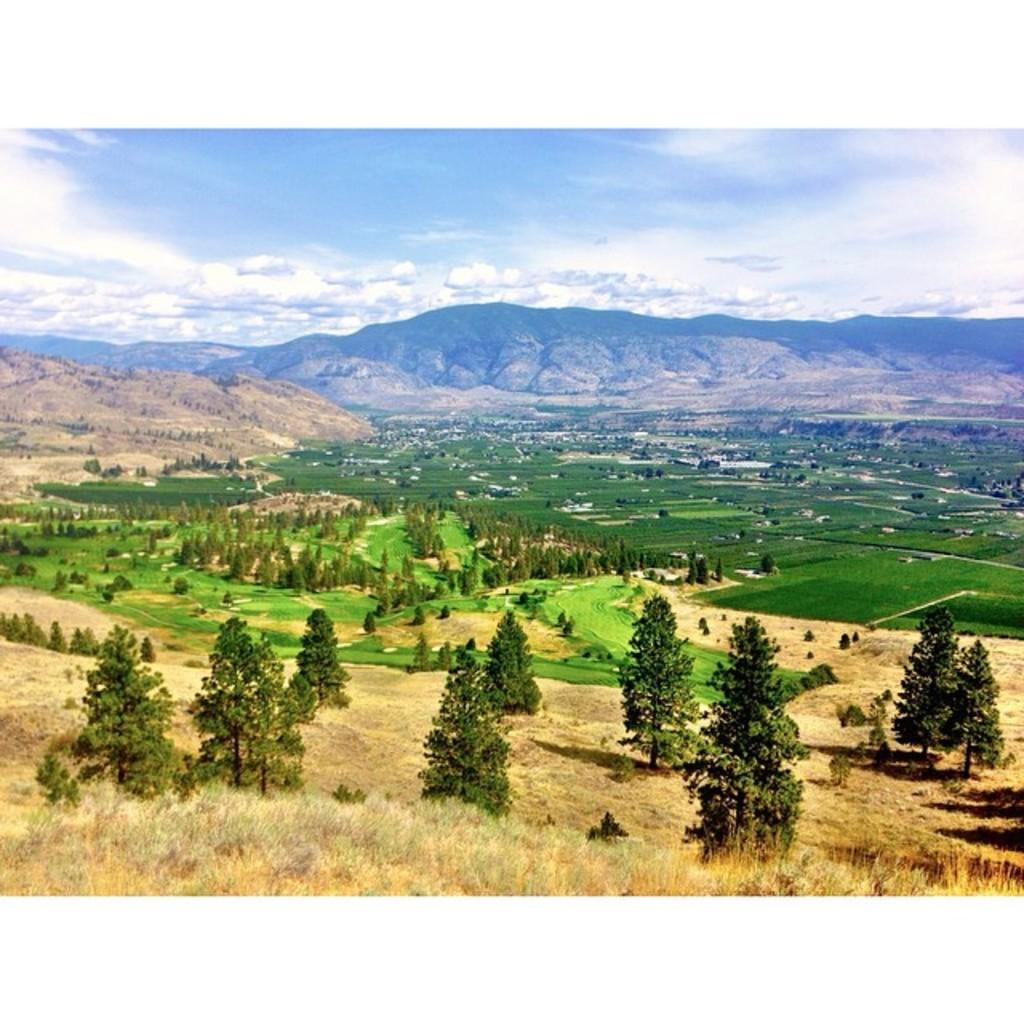What type of vegetation can be seen on the grassland in the image? There are trees on the grassland in the image. What geographical features are visible in the background of the image? There are hills visible in the background of the image. What is visible at the top of the image? The sky is visible at the top of the image. What can be seen in the sky in the image? There are clouds in the sky. What type of silver object can be seen on the grassland in the image? There is no silver object present in the image; it features trees on the grassland, hills in the background, and clouds in the sky. Can you tell me how many crows are perched on the trees in the image? There are no crows present in the image; it only features trees on the grassland. 